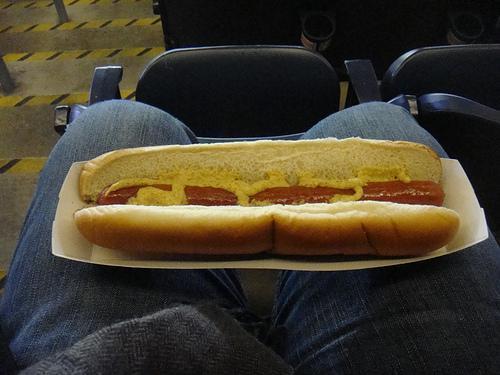How many chairs are in the picture?
Give a very brief answer. 4. How many toilet covers are there?
Give a very brief answer. 0. 